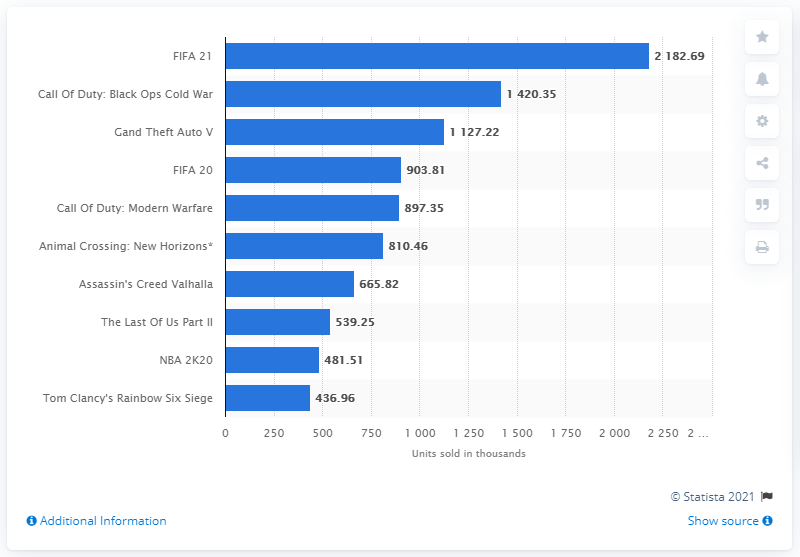Draw attention to some important aspects in this diagram. It is official, the top-selling video game in the UK in 2020 was FIFA 21. 